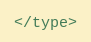Convert code to text. <code><loc_0><loc_0><loc_500><loc_500><_XML_></type>
</code> 